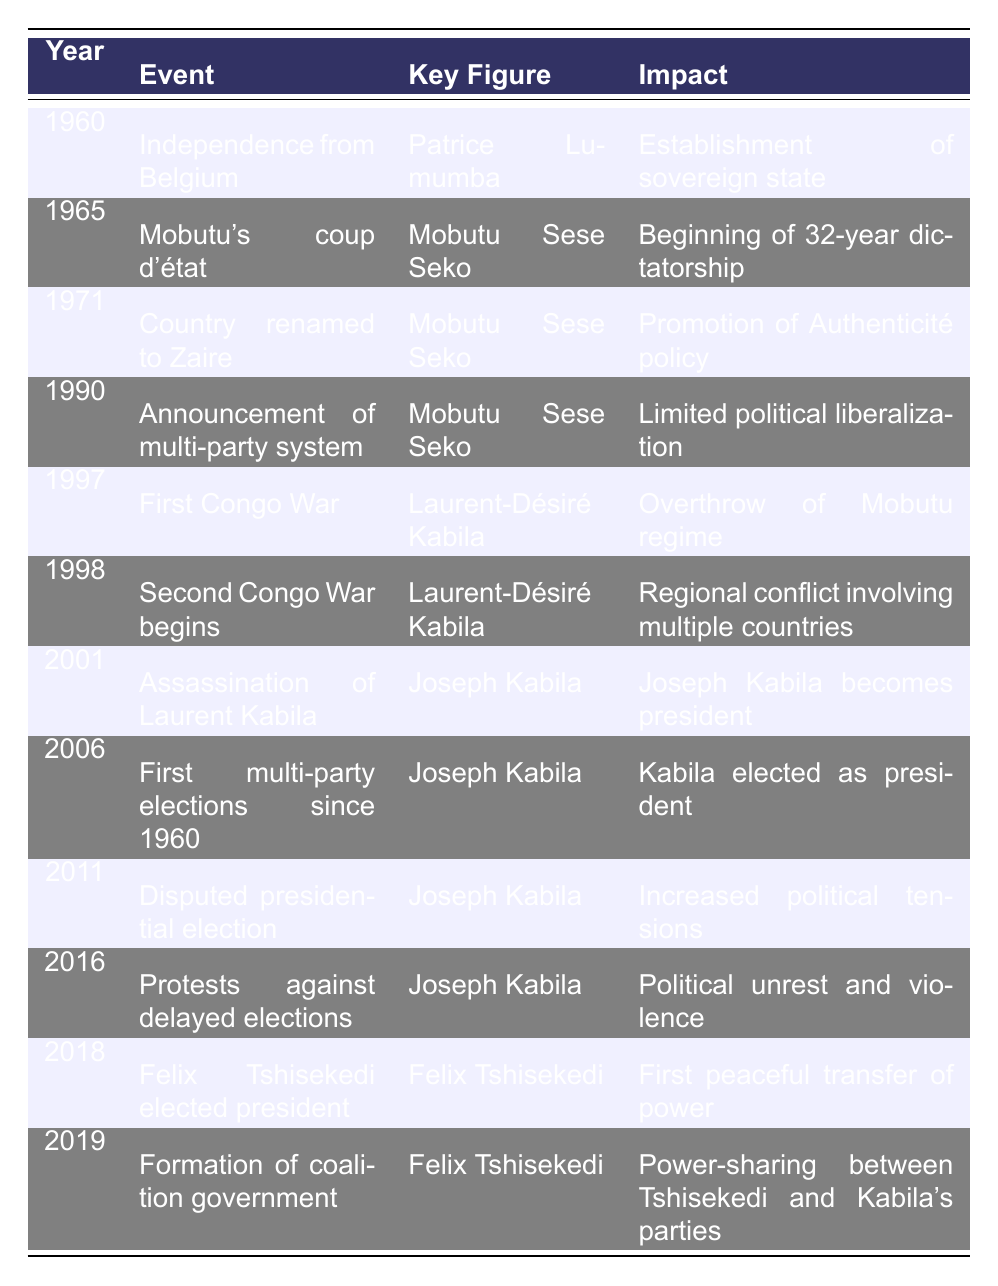What significant event occurred in the DRC in 1960? The table indicates that the significant event in 1960 was the independence from Belgium, led by Patrice Lumumba, marking the establishment of a sovereign state.
Answer: Independence from Belgium Who was the key figure in the 1997 event? According to the table, the key figure in the 1997 event, which was the First Congo War, was Laurent-Désiré Kabila.
Answer: Laurent-Désiré Kabila What impact did the 2006 elections have? The 2006 elections were the first multi-party elections since 1960, resulting in Joseph Kabila being elected as president, which indicates a significant moment in the country's political history.
Answer: Kabila elected as president Was the 2011 presidential election disputed? The table states that the 2011 presidential election was indeed disputed, leading to increased political tensions in the country.
Answer: Yes What was the impact of the Second Congo War in 1998? The table mentions that the impact of the Second Congo War, which began in 1998, was that it resulted in a regional conflict involving multiple countries, illustrating the war's extensive impact beyond DRC's borders.
Answer: Regional conflict involving multiple countries How many major political events were recorded between 1960 and 2020? By reviewing the table, one can count a total of 12 major political events recorded between 1960 and 2020.
Answer: 12 What was the difference in years between Mobutu's coup d'état and Felix Tshisekedi's election? Mobutu's coup d'état occurred in 1965 and Tshisekedi's election was in 2018. The difference is 2018 - 1965 = 53 years.
Answer: 53 years Which key figure was involved in both the 1990 announcement of a multi-party system and the 1997 First Congo War? Both events involved Mobutu Sese Seko; he announced the multi-party system in 1990 and his regime was overthrown in the 1997 First Congo War led by Laurent-Désiré Kabila.
Answer: Mobutu Sese Seko What events led to Joseph Kabila's presidency? Joseph Kabila became president after the assassination of Laurent Kabila in 2001, following which he won the first multi-party elections since 1960 in 2006. This sequence highlights how the assassination changed the leadership and led to Kabila's rise.
Answer: Assassination of Laurent Kabila and elections in 2006 How many political events involve Joseph Kabila as a key figure? The table lists four events involving Joseph Kabila: his presidency starting in 2001, the 2006 elections, the disputed 2011 elections, and the protests in 2016. Therefore, the total is four events.
Answer: 4 events Based on the table, which year had the first peaceful transfer of power? According to the table, the year 2018, marked by Felix Tshisekedi's election, is noted as the first peaceful transfer of power, indicating a significant political milestone for the DRC.
Answer: 2018 